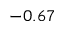Convert formula to latex. <formula><loc_0><loc_0><loc_500><loc_500>- 0 . 6 7</formula> 